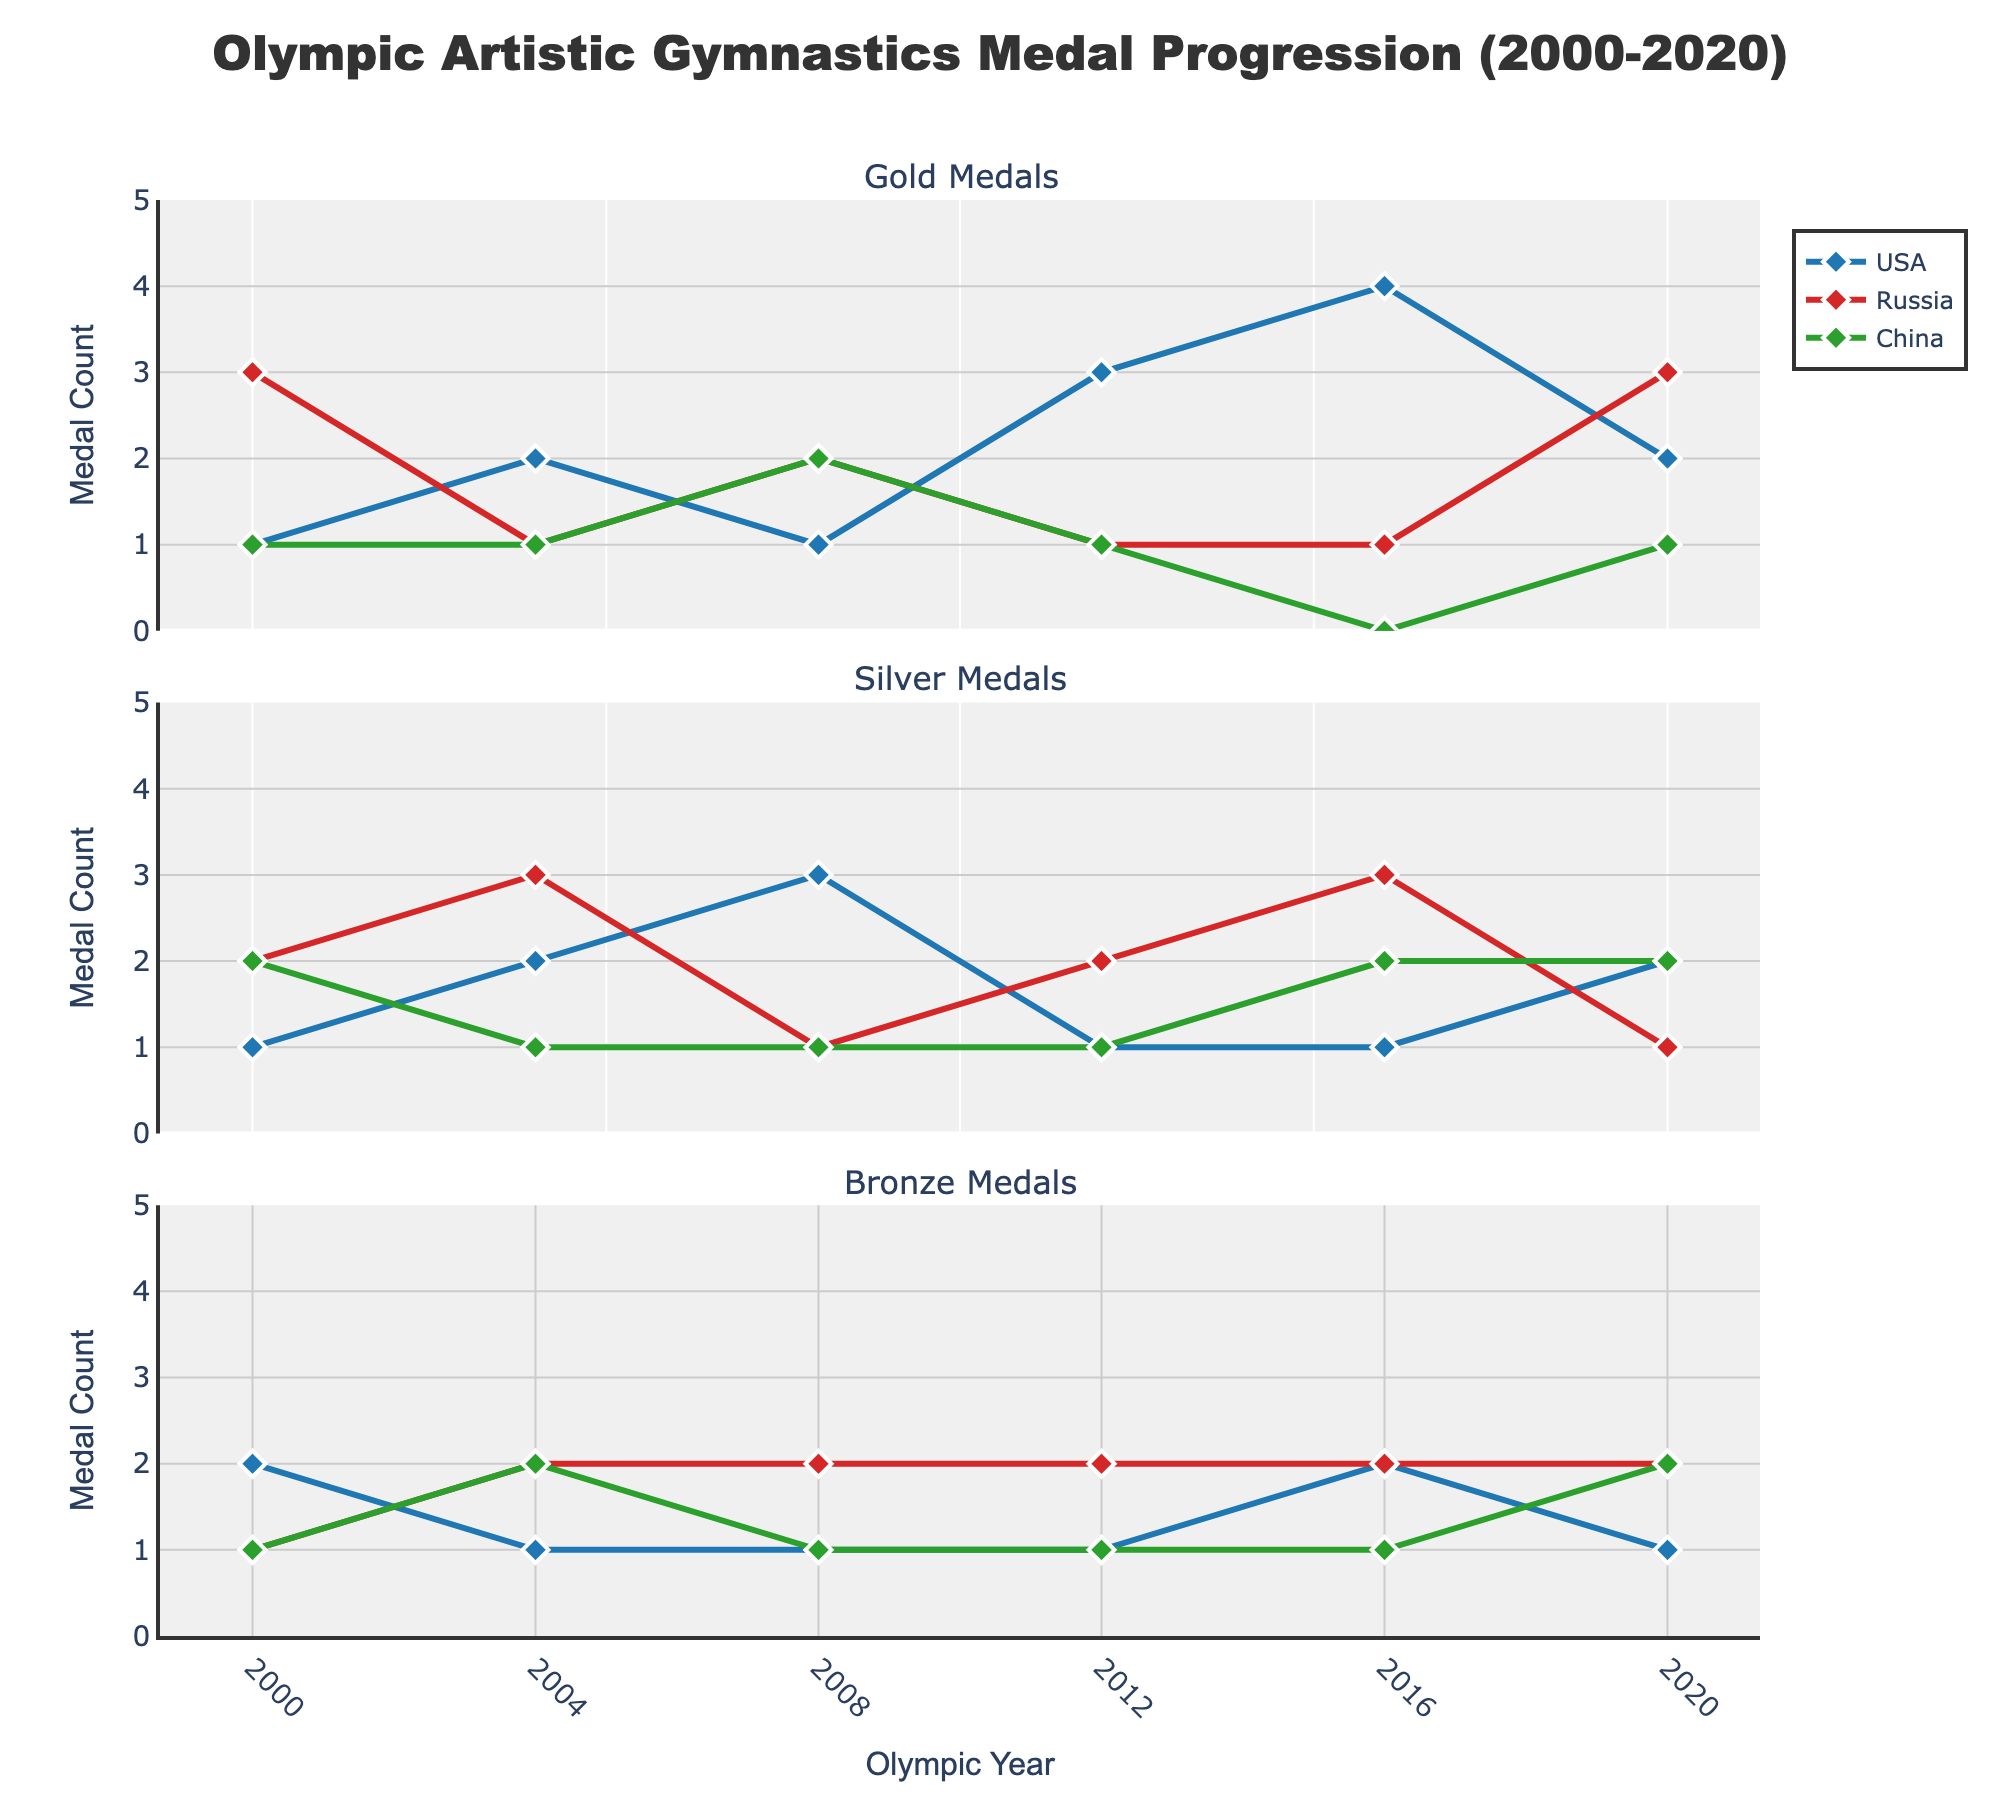What's the title of the figure? The title is located at the top center of the figure, it's usually a summary of the main topic of the plot.
Answer: Olympic Artistic Gymnastics Medal Progression (2000-2020) Which country won the most gold medals in 2016? By tracing the data points in the "Gold Medals" subplot for the year 2016, and comparing the values for each country, we see that the USA has the highest gold medal count.
Answer: USA What is the total number of gold medals won by Russia from 2000 to 2020? Sum up the gold medal counts for Russia across all the years: 3 (2000) + 1 (2004) + 2 (2008) + 1 (2012) + 1 (2016) + 3 (2020) = 11
Answer: 11 How did the bronze medal count for China change from 2008 to 2012? Look at the "Bronze Medals" subplot and find the values for China in 2008 and 2012. The value in 2008 is 1, and in 2012 it is also 1, so there is no change.
Answer: No change Which country showed the most consistent performance in winning medals over the years? Consistency here can be measured by looking at the fluctuations in the number of medals won across all types for each country. The USA consistently features in the top ranks across all the years and medal types with steady increments.
Answer: USA How many silver medals did the USA win in total from 2000 to 2020? Sum the silver medal counts for the USA across all the years: 1 (2000) + 2 (2004) + 3 (2008) + 1 (2012) + 1 (2016) + 2 (2020) = 10
Answer: 10 Did any country win more silver medals than gold medals in 2020? Compare the silver and gold medal counts for each country in the year 2020. Russia won 3 gold and 1 silver, USA won 2 gold and 2 silver, China won 1 gold and 2 silver. So, only China won more silver than gold medals.
Answer: China What is the trend in the number of gold medals for the USA from 2000 to 2020? Observe the "Gold Medals" subplot for the USA. The count starts at 1 in 2000, rises to 2 in 2004, fluctuates to 1 in 2008, increases to 3 in 2012, then peaks at 4 in 2016, and drops to 2 in 2020.
Answer: Increasing trend overall Which year did China win the highest number of bronze medals? Look at the "Bronze Medals" subplot for China and compare the values across all years. The highest number, 2, is in the year 2020.
Answer: 2020 